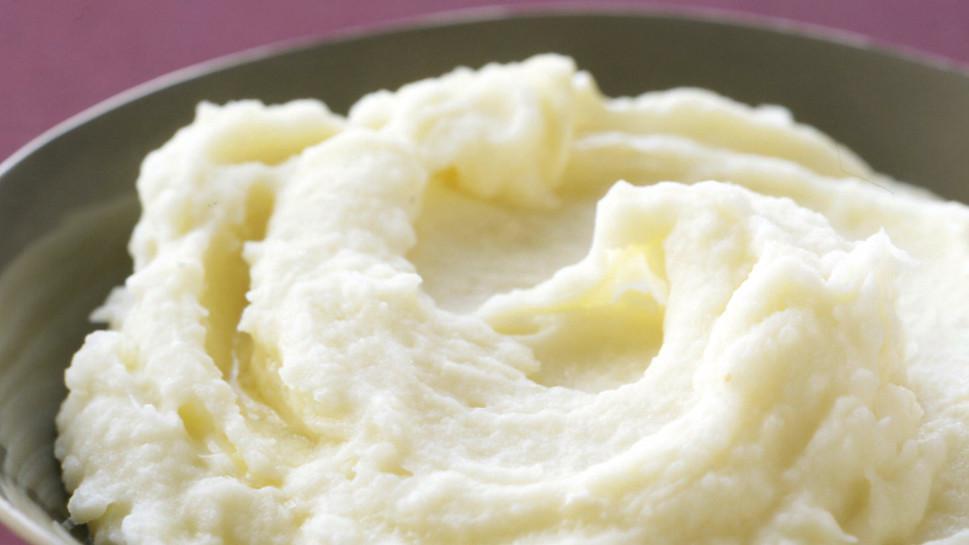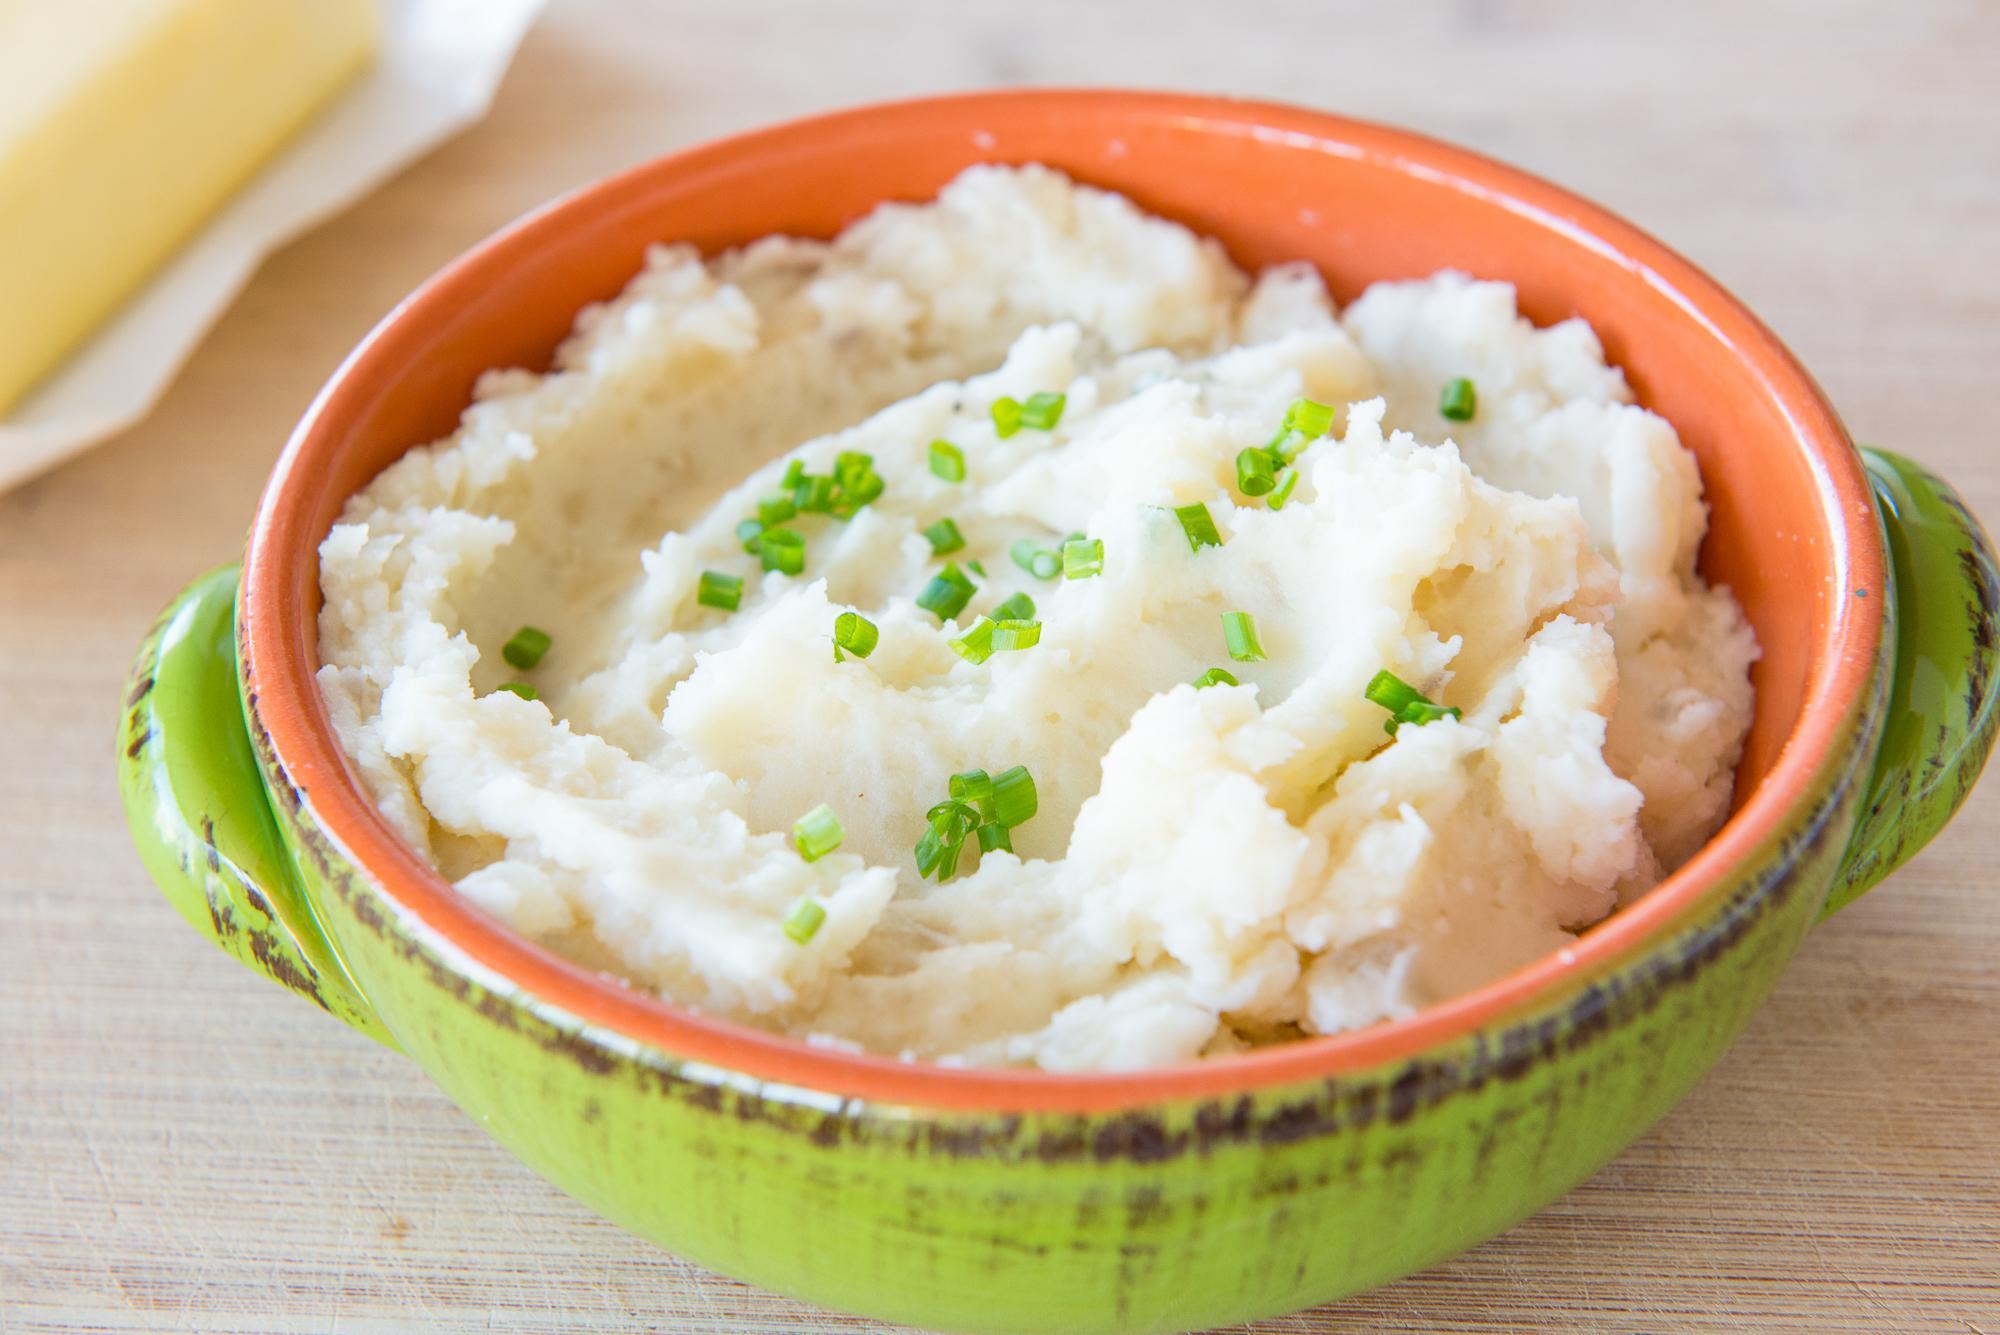The first image is the image on the left, the second image is the image on the right. Examine the images to the left and right. Is the description "There is a green bowl in one of the images" accurate? Answer yes or no. Yes. The first image is the image on the left, the second image is the image on the right. Examine the images to the left and right. Is the description "A spoon is next to a bowl in at least one image." accurate? Answer yes or no. No. 